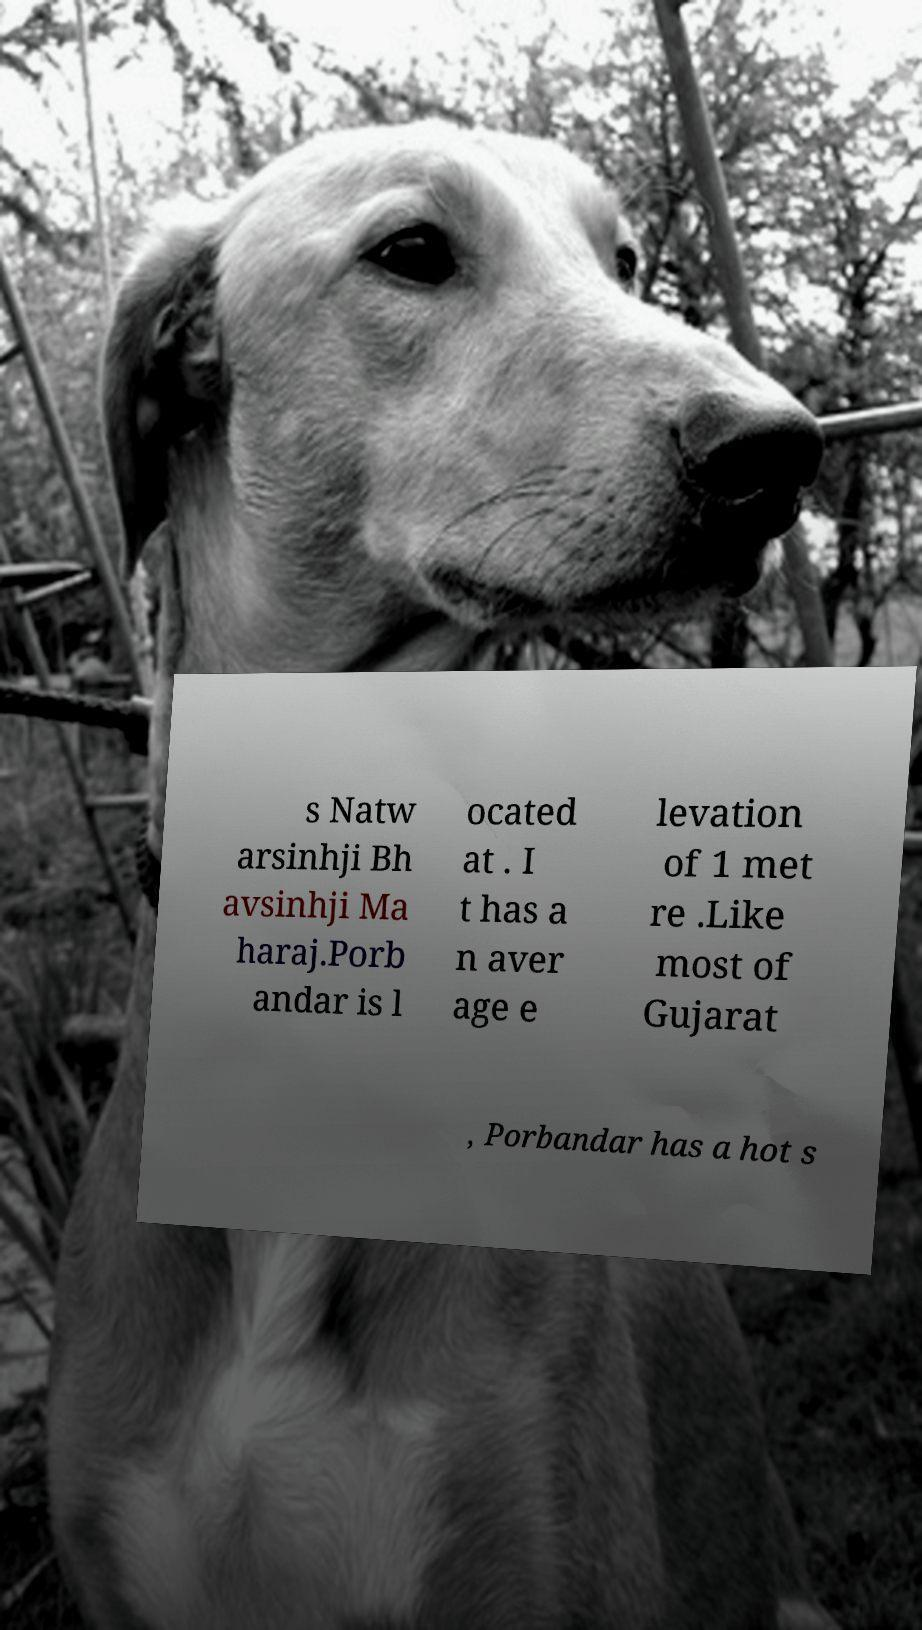Could you extract and type out the text from this image? s Natw arsinhji Bh avsinhji Ma haraj.Porb andar is l ocated at . I t has a n aver age e levation of 1 met re .Like most of Gujarat , Porbandar has a hot s 